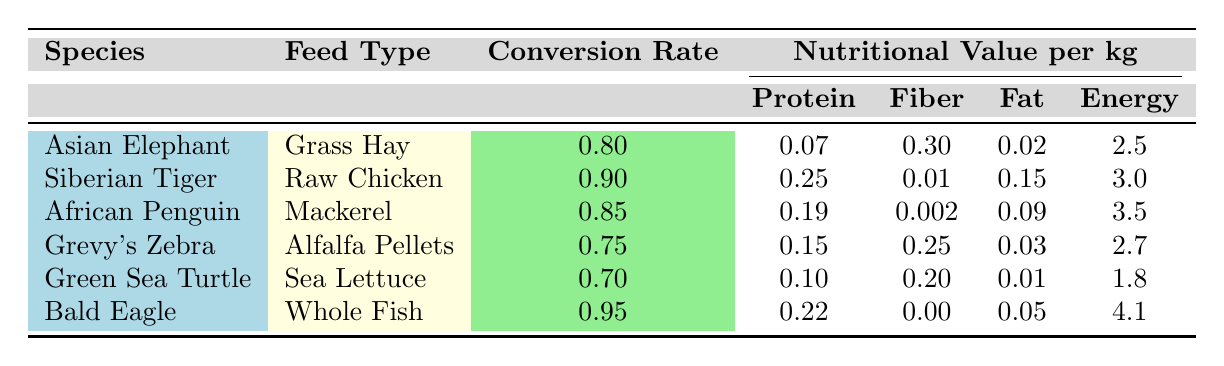What is the conversion rate for the Greenland Sea Turtle? The table lists the Green Sea Turtle with a conversion rate of 0.7, as shown in the corresponding row.
Answer: 0.7 Which animal has the highest protein content in its feed? Looking through the table, the Siberian Tiger has the highest protein content of 0.25 per kg in its feed (Raw Chicken).
Answer: Siberian Tiger What is the total energy value provided by the feed types for the Bald Eagle and African Penguin? The Bald Eagle has an energy value of 4.1 and the African Penguin has 3.5. Summing these gives 4.1 + 3.5 = 7.6.
Answer: 7.6 Is the fiber content of Alfalfa Pellets greater than that of Sea Lettuce? The fiber content of Alfalfa Pellets is 0.25, while Sea Lettuce has 0.20. Since 0.25 is greater than 0.20, the statement is true.
Answer: Yes What feed type is used for the Grevy's Zebra and how does its conversion rate compare to that of the Asian Elephant? The Grevy's Zebra is fed Alfalfa Pellets, which have a conversion rate of 0.75. The Asian Elephant is fed Grass Hay with a conversion rate of 0.80. Since 0.75 is less than 0.80, the conversion rate for the Grevy's Zebra is lower.
Answer: Lower 